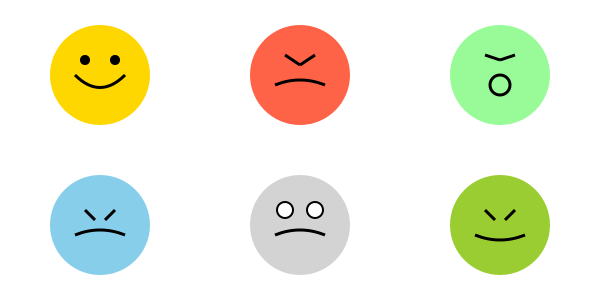As a theater director, you're conducting a workshop on portraying emotions through facial expressions. Using the series of character emotion sketches provided, identify which emotion is most likely to be associated with raised eyebrows, widened eyes, and an open mouth in a circular shape? To answer this question, let's analyze each emotion sketch step-by-step:

1. Joy (top left): Characterized by upturned mouth corners and slightly squinted eyes.
2. Anger (top center): Shows furrowed brows and a straight or downturned mouth.
3. Surprise (top right): Features raised eyebrows, widened eyes, and an open mouth in a circular shape.
4. Sadness (bottom left): Displays downturned mouth corners and slightly closed eyes.
5. Fear (bottom center): Shows widened eyes and a slightly open mouth, but not as exaggerated as surprise.
6. Disgust (bottom right): Characterized by a wrinkled nose and raised upper lip.

The emotion that best matches the description of "raised eyebrows, widened eyes, and an open mouth in a circular shape" is surprise. This combination of facial features is typically associated with a sudden, unexpected event or revelation, causing the face to open up in astonishment.

In theater, actors often exaggerate this expression to convey surprise to the audience, even from a distance. The raised eyebrows lift the entire forehead, the widened eyes create a sense of alertness or shock, and the circular open mouth suggests a gasp or sudden intake of breath.
Answer: Surprise 